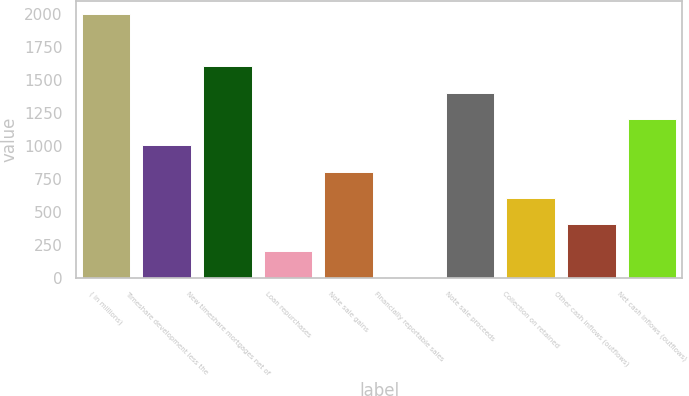Convert chart to OTSL. <chart><loc_0><loc_0><loc_500><loc_500><bar_chart><fcel>( in millions)<fcel>Timeshare development less the<fcel>New timeshare mortgages net of<fcel>Loan repurchases<fcel>Note sale gains<fcel>Financially reportable sales<fcel>Note sale proceeds<fcel>Collection on retained<fcel>Other cash inflows (outflows)<fcel>Net cash inflows (outflows)<nl><fcel>2003<fcel>1003.5<fcel>1603.2<fcel>203.9<fcel>803.6<fcel>4<fcel>1403.3<fcel>603.7<fcel>403.8<fcel>1203.4<nl></chart> 